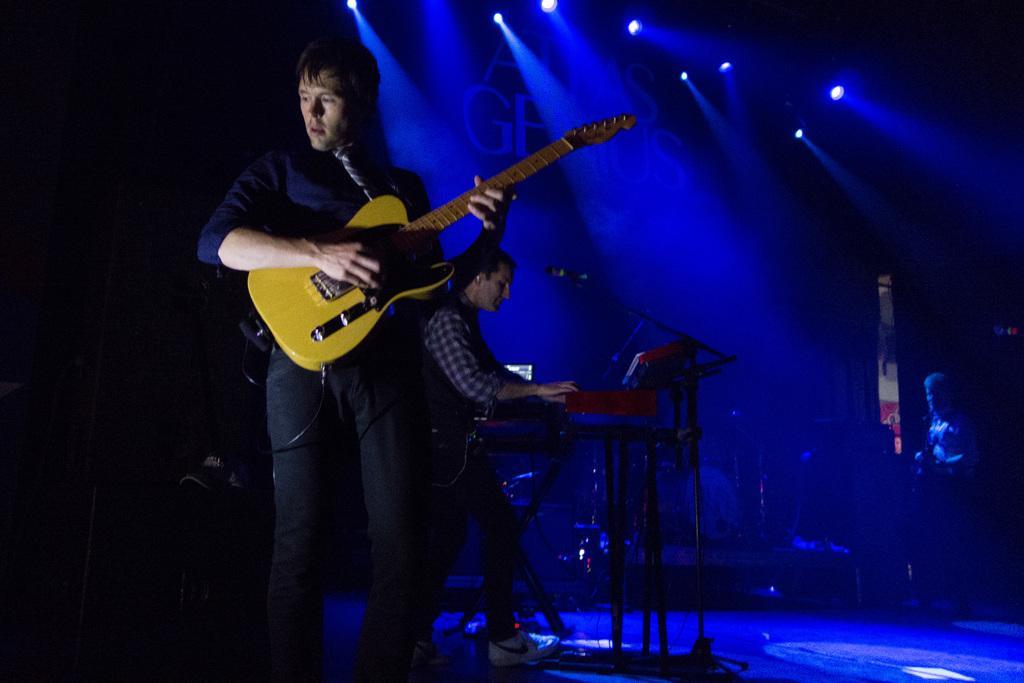In one or two sentences, can you explain what this image depicts? In this image I can see a man is standing and holding a guitar. In the background I can another person and I can see a mic in front of him. In the background I can see few lights. 